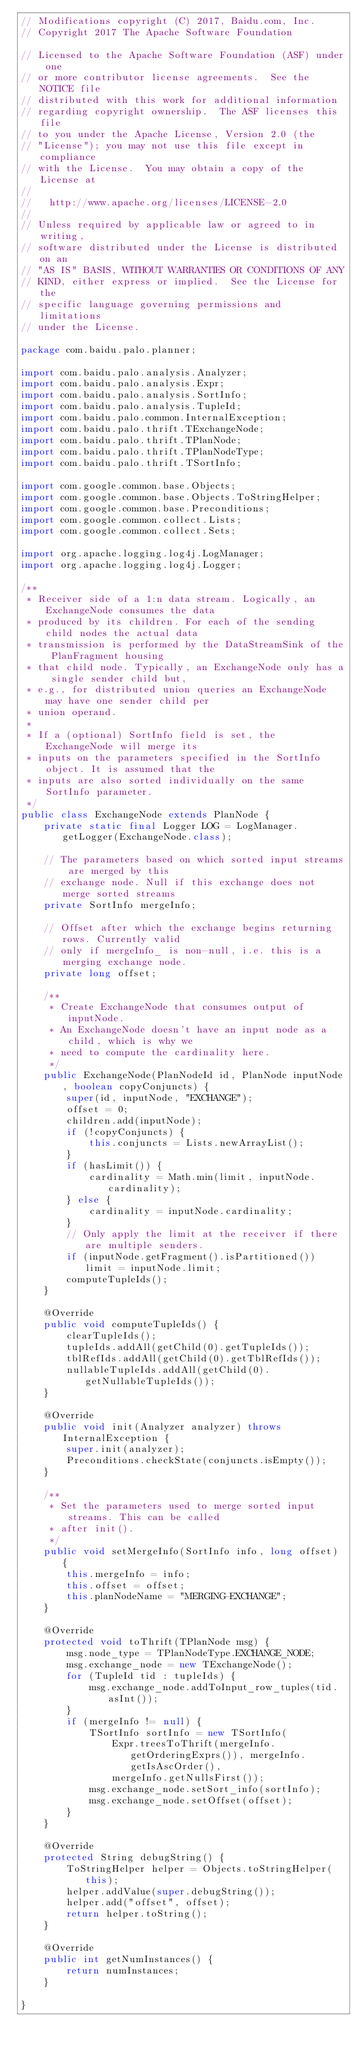Convert code to text. <code><loc_0><loc_0><loc_500><loc_500><_Java_>// Modifications copyright (C) 2017, Baidu.com, Inc.
// Copyright 2017 The Apache Software Foundation

// Licensed to the Apache Software Foundation (ASF) under one
// or more contributor license agreements.  See the NOTICE file
// distributed with this work for additional information
// regarding copyright ownership.  The ASF licenses this file
// to you under the Apache License, Version 2.0 (the
// "License"); you may not use this file except in compliance
// with the License.  You may obtain a copy of the License at
//
//   http://www.apache.org/licenses/LICENSE-2.0
//
// Unless required by applicable law or agreed to in writing,
// software distributed under the License is distributed on an
// "AS IS" BASIS, WITHOUT WARRANTIES OR CONDITIONS OF ANY
// KIND, either express or implied.  See the License for the
// specific language governing permissions and limitations
// under the License.

package com.baidu.palo.planner;

import com.baidu.palo.analysis.Analyzer;
import com.baidu.palo.analysis.Expr;
import com.baidu.palo.analysis.SortInfo;
import com.baidu.palo.analysis.TupleId;
import com.baidu.palo.common.InternalException;
import com.baidu.palo.thrift.TExchangeNode;
import com.baidu.palo.thrift.TPlanNode;
import com.baidu.palo.thrift.TPlanNodeType;
import com.baidu.palo.thrift.TSortInfo;

import com.google.common.base.Objects;
import com.google.common.base.Objects.ToStringHelper;
import com.google.common.base.Preconditions;
import com.google.common.collect.Lists;
import com.google.common.collect.Sets;

import org.apache.logging.log4j.LogManager;
import org.apache.logging.log4j.Logger;

/**
 * Receiver side of a 1:n data stream. Logically, an ExchangeNode consumes the data
 * produced by its children. For each of the sending child nodes the actual data
 * transmission is performed by the DataStreamSink of the PlanFragment housing
 * that child node. Typically, an ExchangeNode only has a single sender child but,
 * e.g., for distributed union queries an ExchangeNode may have one sender child per
 * union operand.
 *
 * If a (optional) SortInfo field is set, the ExchangeNode will merge its
 * inputs on the parameters specified in the SortInfo object. It is assumed that the
 * inputs are also sorted individually on the same SortInfo parameter.
 */
public class ExchangeNode extends PlanNode {
    private static final Logger LOG = LogManager.getLogger(ExchangeNode.class);

    // The parameters based on which sorted input streams are merged by this
    // exchange node. Null if this exchange does not merge sorted streams
    private SortInfo mergeInfo;

    // Offset after which the exchange begins returning rows. Currently valid
    // only if mergeInfo_ is non-null, i.e. this is a merging exchange node.
    private long offset;

    /**
     * Create ExchangeNode that consumes output of inputNode.
     * An ExchangeNode doesn't have an input node as a child, which is why we
     * need to compute the cardinality here.
     */
    public ExchangeNode(PlanNodeId id, PlanNode inputNode, boolean copyConjuncts) {
        super(id, inputNode, "EXCHANGE");
        offset = 0;
        children.add(inputNode);
        if (!copyConjuncts) {
            this.conjuncts = Lists.newArrayList();
        }
        if (hasLimit()) {
            cardinality = Math.min(limit, inputNode.cardinality);
        } else {
            cardinality = inputNode.cardinality;
        }
        // Only apply the limit at the receiver if there are multiple senders.
        if (inputNode.getFragment().isPartitioned()) limit = inputNode.limit;
        computeTupleIds();
    }

    @Override
    public void computeTupleIds() {
        clearTupleIds();
        tupleIds.addAll(getChild(0).getTupleIds());
        tblRefIds.addAll(getChild(0).getTblRefIds());
        nullableTupleIds.addAll(getChild(0).getNullableTupleIds());
    }

    @Override
    public void init(Analyzer analyzer) throws InternalException {
        super.init(analyzer);
        Preconditions.checkState(conjuncts.isEmpty());
    }

    /**
     * Set the parameters used to merge sorted input streams. This can be called
     * after init().
     */
    public void setMergeInfo(SortInfo info, long offset) {
        this.mergeInfo = info;
        this.offset = offset;
        this.planNodeName = "MERGING-EXCHANGE";
    }

    @Override
    protected void toThrift(TPlanNode msg) {
        msg.node_type = TPlanNodeType.EXCHANGE_NODE;
        msg.exchange_node = new TExchangeNode();
        for (TupleId tid : tupleIds) {
            msg.exchange_node.addToInput_row_tuples(tid.asInt());
        }
        if (mergeInfo != null) {
            TSortInfo sortInfo = new TSortInfo(
                Expr.treesToThrift(mergeInfo.getOrderingExprs()), mergeInfo.getIsAscOrder(),
                mergeInfo.getNullsFirst());
            msg.exchange_node.setSort_info(sortInfo);
            msg.exchange_node.setOffset(offset);
        }
    }

    @Override
    protected String debugString() {
        ToStringHelper helper = Objects.toStringHelper(this);
        helper.addValue(super.debugString());
        helper.add("offset", offset);
        return helper.toString();
    }

    @Override
    public int getNumInstances() {
        return numInstances;
    }

}
</code> 